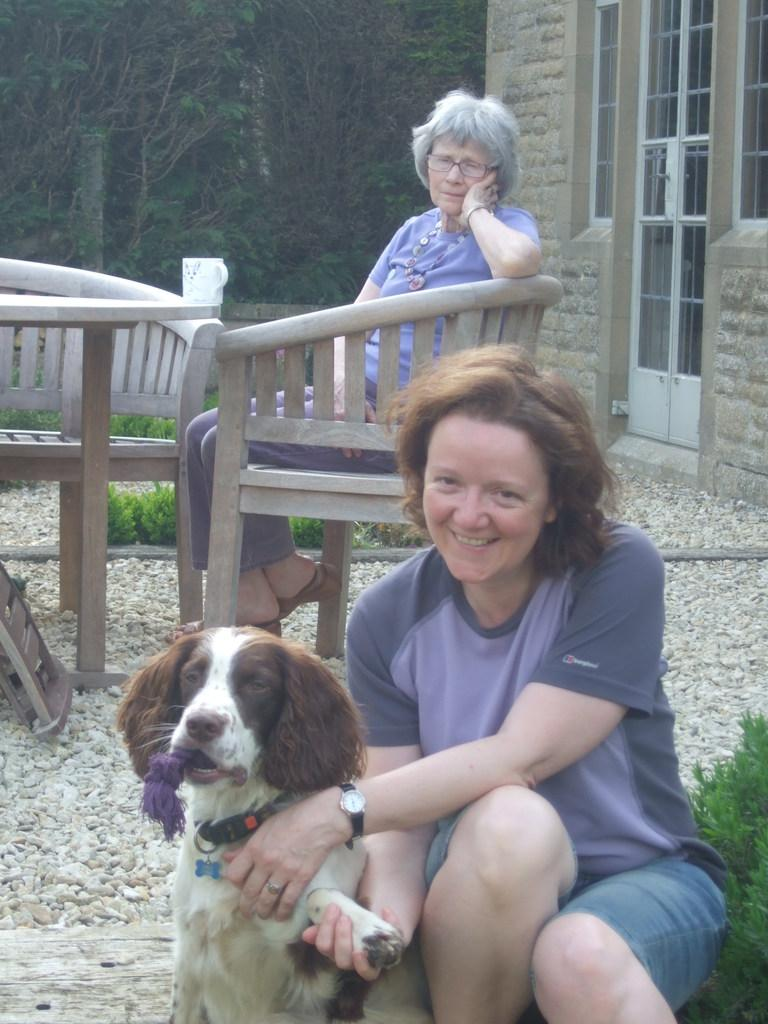How many people are in the image? There are two women in the image. What is the other living creature in the image? There is a dog in the image. What is the position of one of the women in the image? One of the women is sitting on a chair. What piece of furniture is present in the image? There is a table in the image. What can be seen in the distance in the image? There is a building visible in the background of the image. What type of kite is being flown by the dog in the image? There is no kite present in the image, and the dog is not flying anything. 